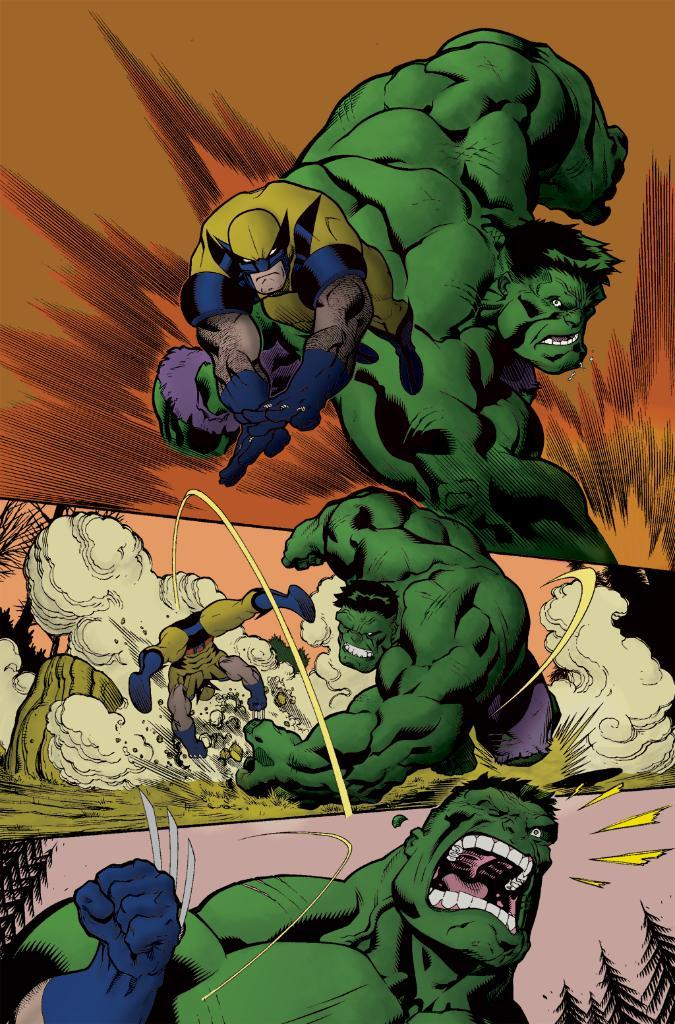What is the main subject of the picture? The main subject of the picture is three animated images. Can you describe one of the animated images? One of the animated images is of a person. What color is the person in the animated image? The person in the animated image is in green color. What type of pan can be seen in the image? There is no pan present in the image; it features three animated images. How does the person in the green animated image slip in the image? The person in the green animated image does not slip in the image, as there is no indication of movement or slipping. 